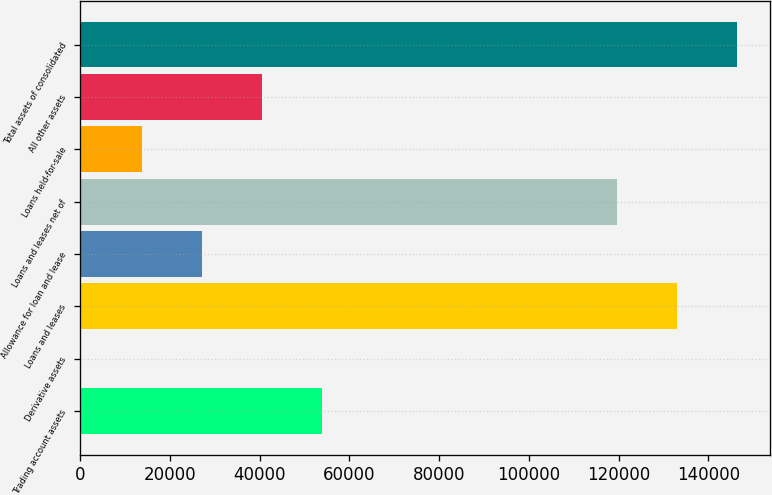<chart> <loc_0><loc_0><loc_500><loc_500><bar_chart><fcel>Trading account assets<fcel>Derivative assets<fcel>Loans and leases<fcel>Allowance for loan and lease<fcel>Loans and leases net of<fcel>Loans held-for-sale<fcel>All other assets<fcel>Total assets of consolidated<nl><fcel>53972.2<fcel>333<fcel>132979<fcel>27152.6<fcel>119569<fcel>13742.8<fcel>40562.4<fcel>146389<nl></chart> 